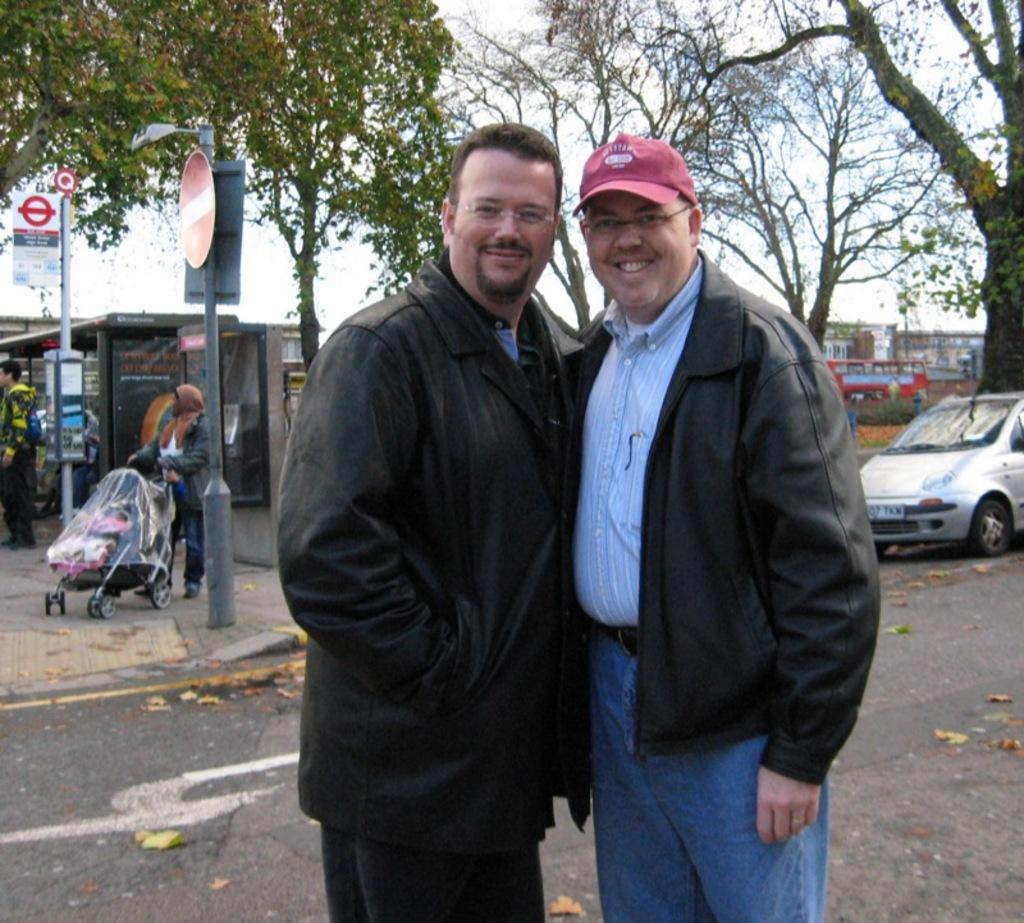What can be seen in the image involving human presence? There are people standing in the image. What is the main feature of the landscape in the image? There is a road in the image. What types of transportation are present in the image? There are vehicles in the image. What type of natural element is visible in the image? There are trees visible in the image. Where are some of the people located in the image? There are people on the footpath in the image. What is visible in the background of the image? The sky is visible in the image. Can you tell me how many chickens are crossing the road in the image? There are no chickens present in the image; it features people, a road, vehicles, trees, and the sky. What type of knife is being used by the person in the image? There is no knife present in the image. 